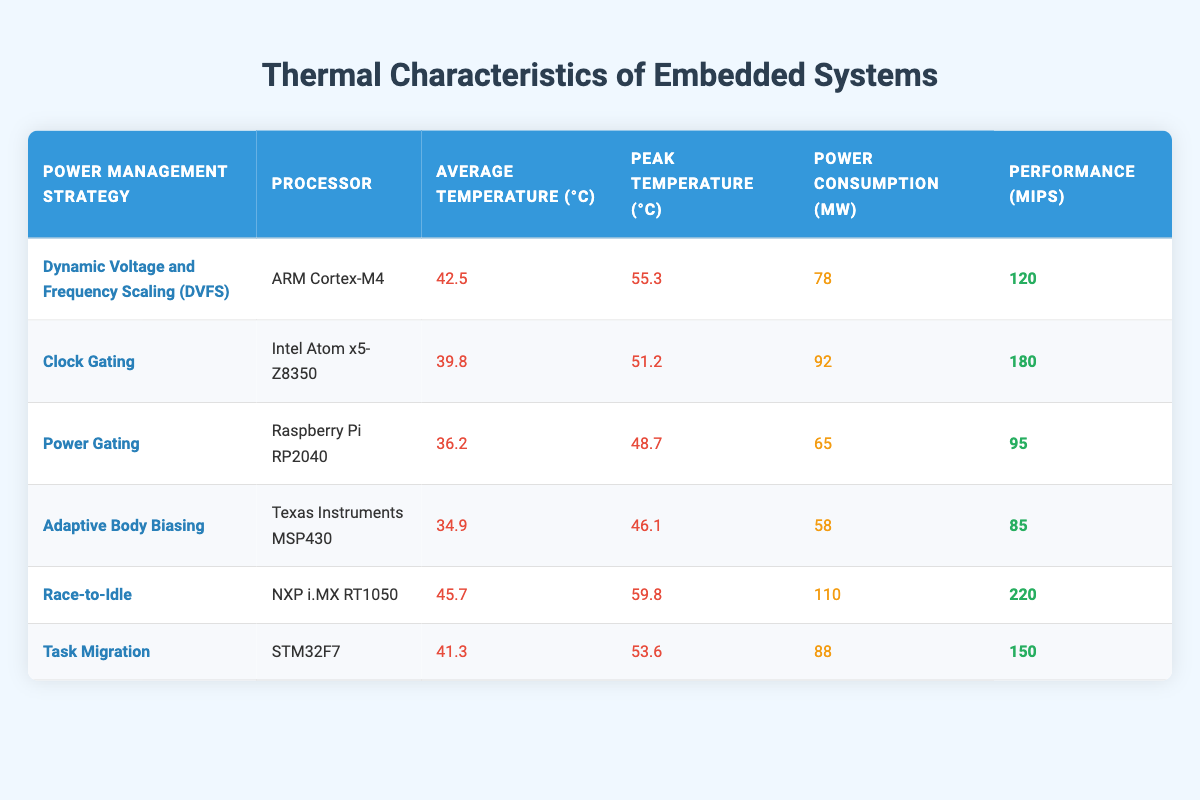What is the average temperature of the Power Gating strategy? The average temperature for the Power Gating strategy is listed in the table as 36.2°C.
Answer: 36.2°C Which power management strategy has the highest peak temperature? By reviewing the Peak Temperature column, the Race-to-Idle strategy shows the highest peak temperature of 59.8°C.
Answer: Race-to-Idle Is the average temperature of the Clock Gating strategy greater than the average temperature of the Task Migration strategy? The average temperature for Clock Gating is 39.8°C, and for Task Migration, it is 41.3°C. Since 39.8 < 41.3, Clock Gating has a lower average temperature.
Answer: No What is the difference in power consumption between the Adaptive Body Biasing and Race-to-Idle strategies? Power consumption for Adaptive Body Biasing is 58 mW and for Race-to-Idle is 110 mW. The difference is calculated as 110 - 58 = 52 mW.
Answer: 52 mW Which processor has the lowest average temperature and what is that temperature? The data shows that the Texas Instruments MSP430 with Adaptive Body Biasing has the lowest average temperature at 34.9°C.
Answer: Texas Instruments MSP430, 34.9°C If you combine the average temperatures of all strategies, what is the average temperature? Adding the average temperatures (42.5 + 39.8 + 36.2 + 34.9 + 45.7 + 41.3) gives a total of 240.4°C. Dividing by 6 (total strategies) yields an average temperature of 40.067°C.
Answer: 40.067°C Does the Race-to-Idle strategy consume more power than the Power Gating strategy? From the table, Race-to-Idle has a power consumption of 110 mW and Power Gating has 65 mW. Since 110 > 65, it confirms that Race-to-Idle consumes more power.
Answer: Yes How many strategies have a performance rating of over 150 MIPS? The strategies with performance ratings over 150 MIPS are Clock Gating (180 MIPS) and Race-to-Idle (220 MIPS). Therefore, there are 2 such strategies.
Answer: 2 What is the performance-to-power consumption ratio for the ARM Cortex-M4 using DVFS? The performance is 120 MIPS, and the power consumption is 78 mW. Thus, the ratio is 120/78 = 1.538 MIPS/mW.
Answer: 1.538 MIPS/mW 